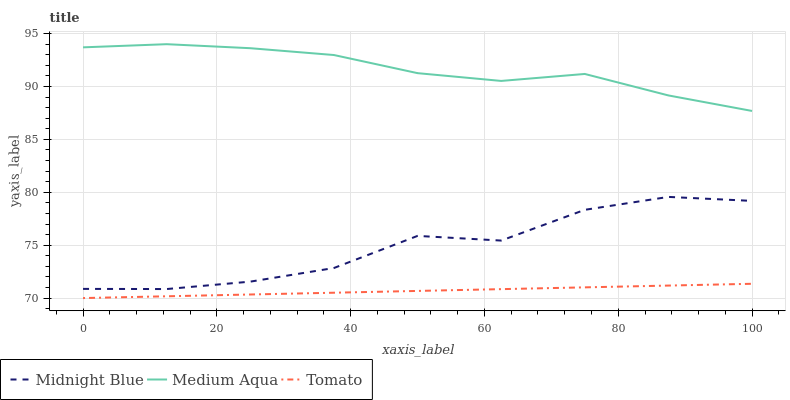Does Tomato have the minimum area under the curve?
Answer yes or no. Yes. Does Medium Aqua have the maximum area under the curve?
Answer yes or no. Yes. Does Midnight Blue have the minimum area under the curve?
Answer yes or no. No. Does Midnight Blue have the maximum area under the curve?
Answer yes or no. No. Is Tomato the smoothest?
Answer yes or no. Yes. Is Midnight Blue the roughest?
Answer yes or no. Yes. Is Medium Aqua the smoothest?
Answer yes or no. No. Is Medium Aqua the roughest?
Answer yes or no. No. Does Tomato have the lowest value?
Answer yes or no. Yes. Does Midnight Blue have the lowest value?
Answer yes or no. No. Does Medium Aqua have the highest value?
Answer yes or no. Yes. Does Midnight Blue have the highest value?
Answer yes or no. No. Is Midnight Blue less than Medium Aqua?
Answer yes or no. Yes. Is Medium Aqua greater than Midnight Blue?
Answer yes or no. Yes. Does Midnight Blue intersect Medium Aqua?
Answer yes or no. No. 